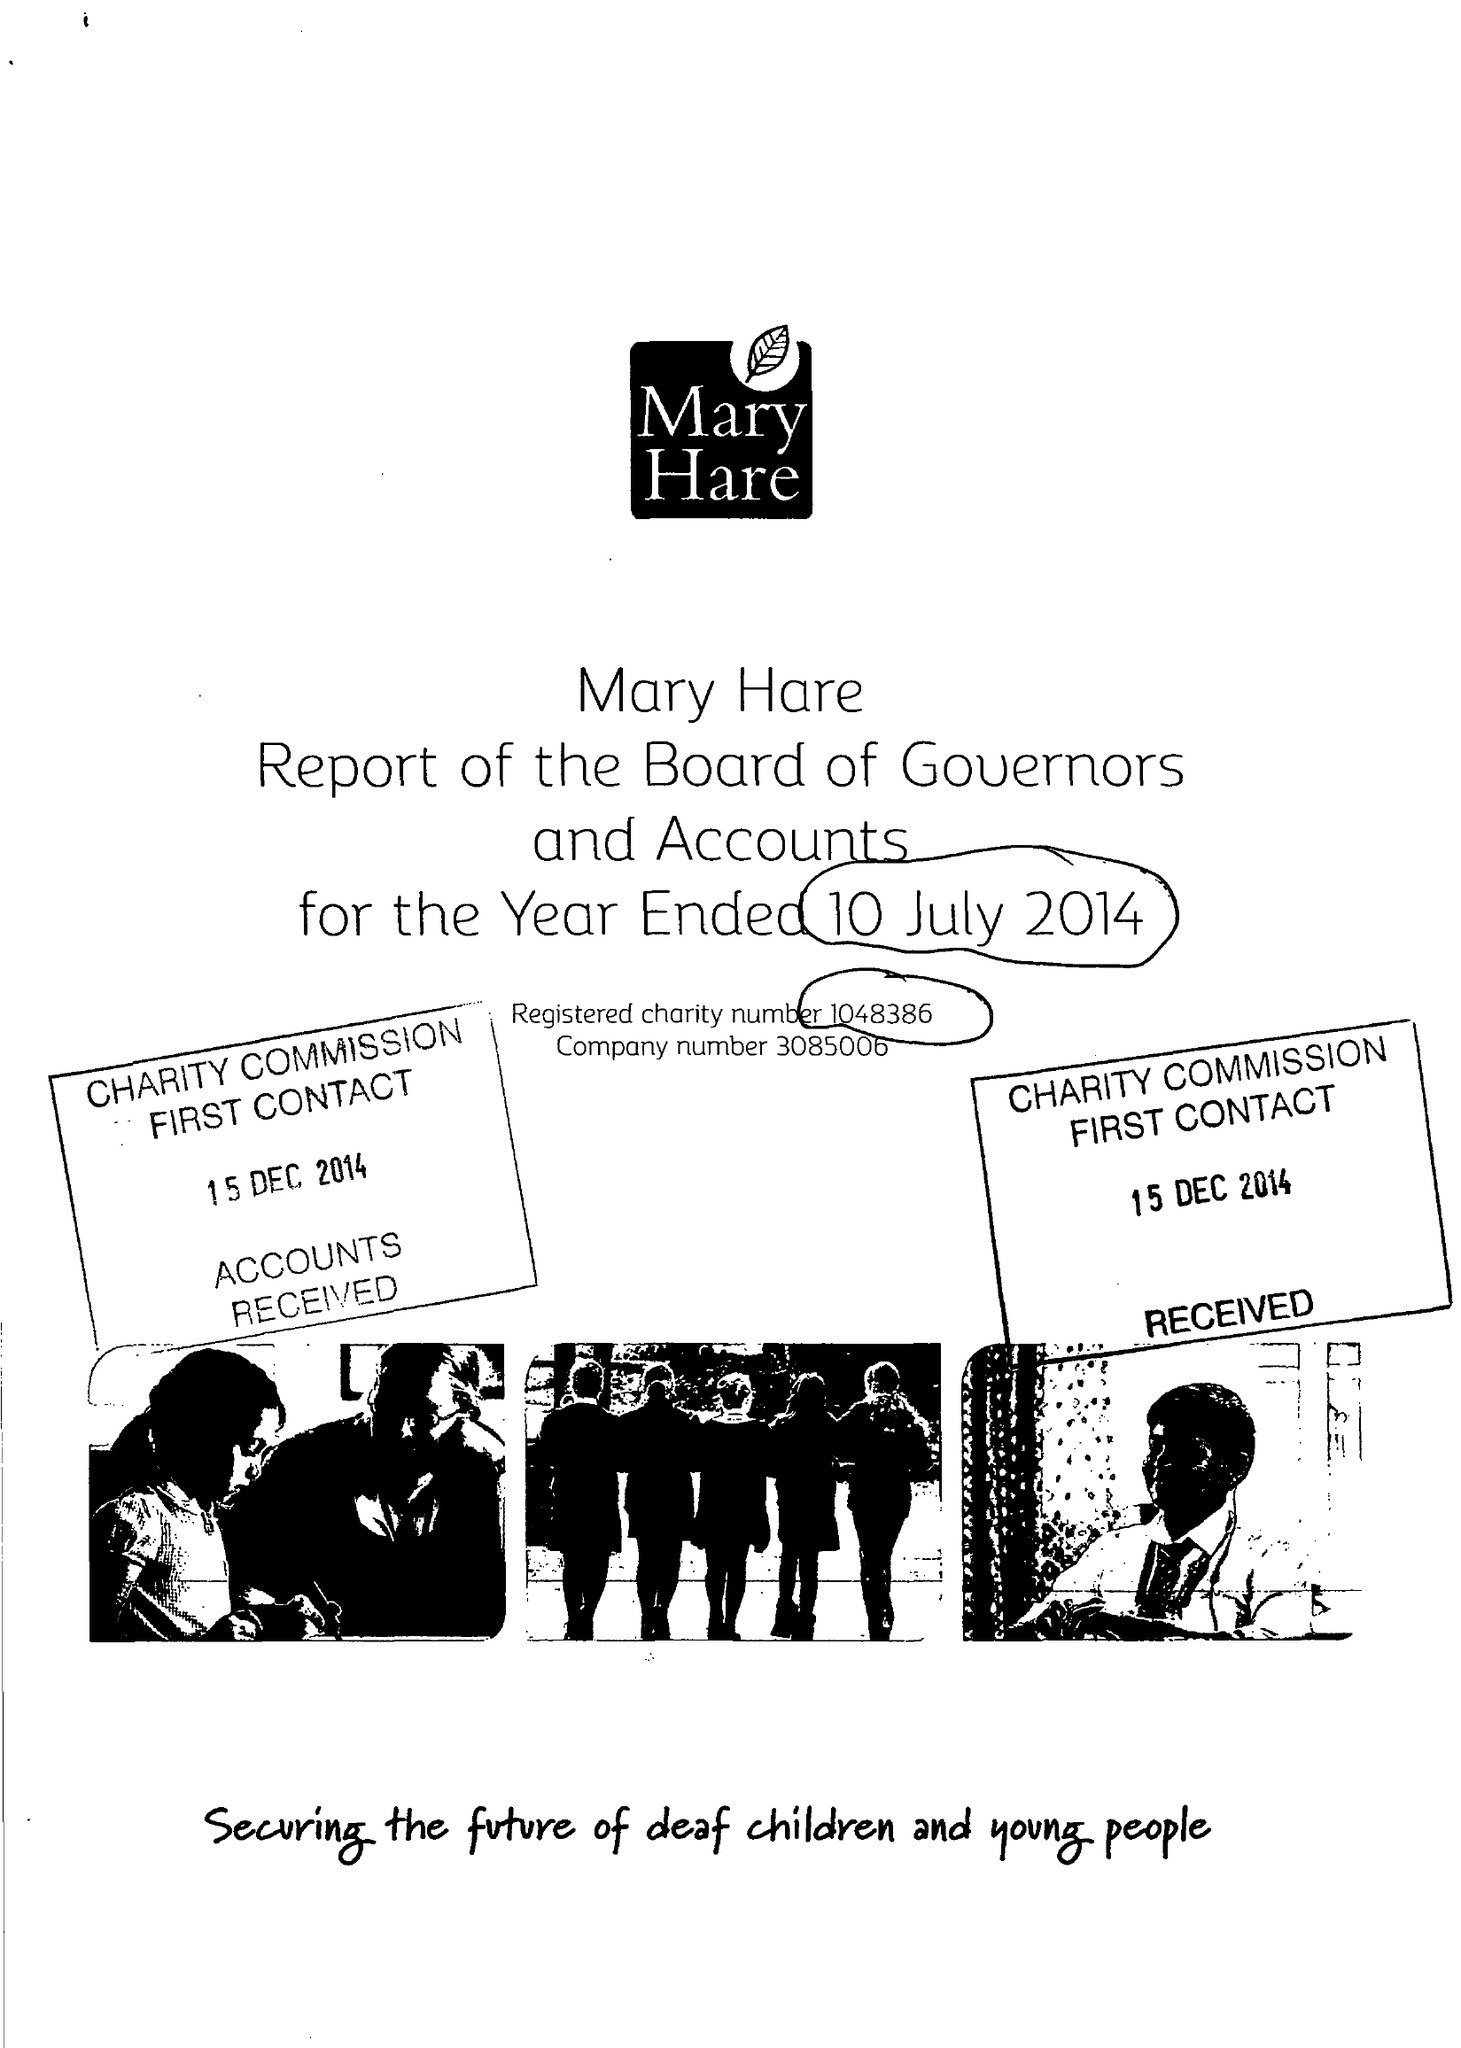What is the value for the address__post_town?
Answer the question using a single word or phrase. NEWBURY 